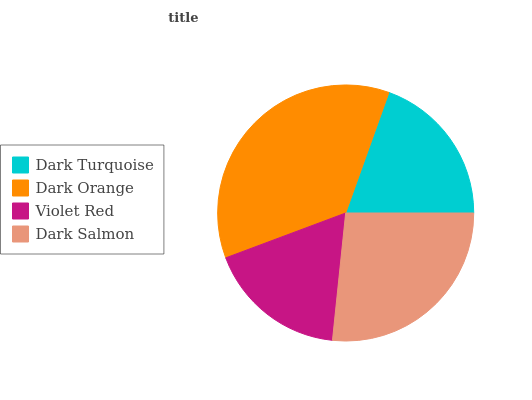Is Violet Red the minimum?
Answer yes or no. Yes. Is Dark Orange the maximum?
Answer yes or no. Yes. Is Dark Orange the minimum?
Answer yes or no. No. Is Violet Red the maximum?
Answer yes or no. No. Is Dark Orange greater than Violet Red?
Answer yes or no. Yes. Is Violet Red less than Dark Orange?
Answer yes or no. Yes. Is Violet Red greater than Dark Orange?
Answer yes or no. No. Is Dark Orange less than Violet Red?
Answer yes or no. No. Is Dark Salmon the high median?
Answer yes or no. Yes. Is Dark Turquoise the low median?
Answer yes or no. Yes. Is Violet Red the high median?
Answer yes or no. No. Is Dark Orange the low median?
Answer yes or no. No. 